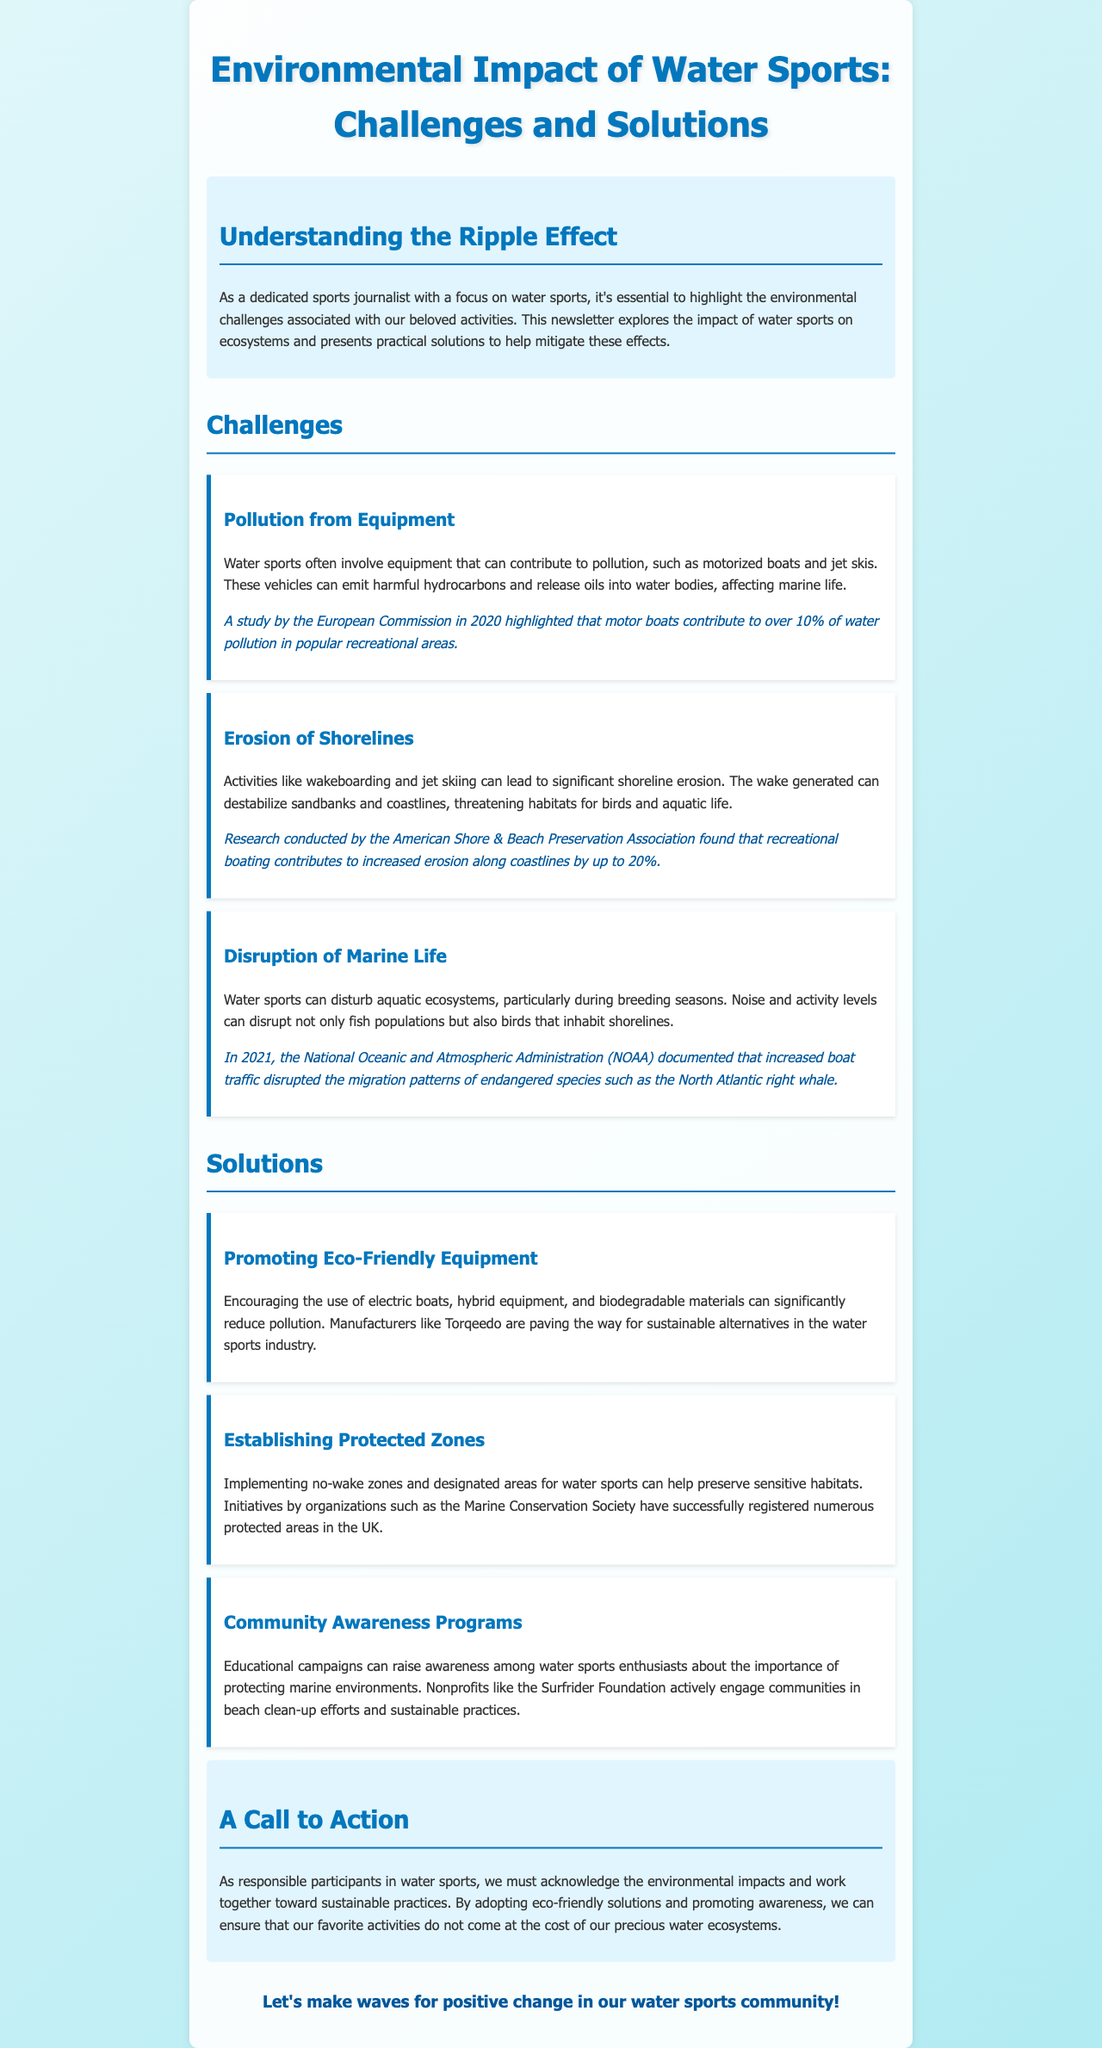What are the two main sections of the newsletter? The newsletter is divided into two main sections: Challenges and Solutions.
Answer: Challenges and Solutions What contributes to over 10% of water pollution in popular recreational areas according to a study by the European Commission? The document mentions that motor boats contribute to over 10% of water pollution.
Answer: Motor boats Which organization documented disruptions to the North Atlantic right whale's migration patterns? The NOAA documented the disruption of migration patterns of the North Atlantic right whale.
Answer: NOAA What is one proposed solution to reduce pollution from water sports? The newsletter suggests promoting the use of electric boats and biodegradable materials as a solution.
Answer: Promoting eco-friendly equipment How much can recreational boating contribute to increased shoreline erosion? The document states that recreational boating can contribute to increased erosion along coastlines by up to 20%.
Answer: 20% What type of awareness programs are suggested in the newsletter? The newsletter mentions that community awareness programs can raise awareness about protecting marine environments.
Answer: Community Awareness Programs 